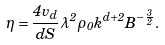Convert formula to latex. <formula><loc_0><loc_0><loc_500><loc_500>\eta = \frac { 4 v _ { d } } { d S } \lambda ^ { 2 } \rho _ { 0 } k ^ { d + 2 } B ^ { - \frac { 3 } { 2 } } .</formula> 